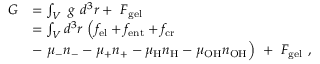<formula> <loc_0><loc_0><loc_500><loc_500>\begin{array} { r l } { G } & { = \int _ { V } g d ^ { 3 } r + F _ { g e l } } \\ & { = \int _ { V } d ^ { 3 } r \left ( f _ { e l } + f _ { e n t } + f _ { c r } } \\ & { - \mu _ { - } n _ { - } - \mu _ { + } n _ { + } - \mu _ { H } n _ { H } - \mu _ { O H } n _ { O H } \right ) + F _ { g e l } \ , } \end{array}</formula> 